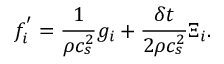Convert formula to latex. <formula><loc_0><loc_0><loc_500><loc_500>f _ { i } ^ { ^ { \prime } } = \frac { 1 } { \rho c _ { s } ^ { 2 } } g _ { i } + \frac { \delta t } { 2 \rho c _ { s } ^ { 2 } } \Xi _ { i } .</formula> 